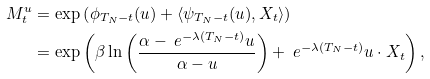Convert formula to latex. <formula><loc_0><loc_0><loc_500><loc_500>M _ { t } ^ { u } & = \exp \left ( \phi _ { T _ { N } - t } ( u ) + \langle \psi _ { T _ { N } - t } ( u ) , X _ { t } \rangle \right ) \\ & = \exp \left ( \beta \ln \left ( \frac { \alpha - \ e ^ { - \lambda ( T _ { N } - t ) } u } { \alpha - u } \right ) + \ e ^ { - \lambda ( T _ { N } - t ) } u \cdot X _ { t } \right ) ,</formula> 